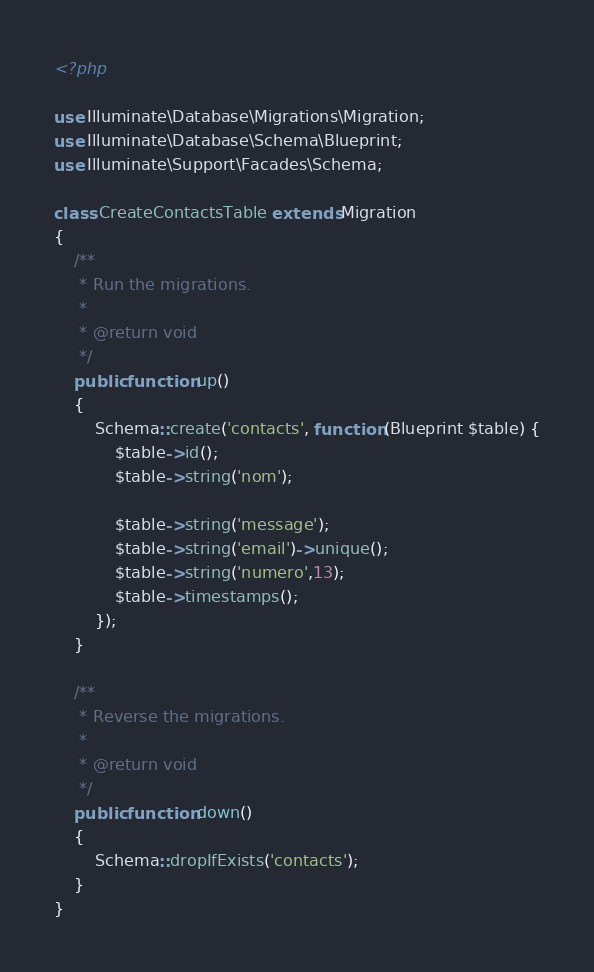Convert code to text. <code><loc_0><loc_0><loc_500><loc_500><_PHP_><?php

use Illuminate\Database\Migrations\Migration;
use Illuminate\Database\Schema\Blueprint;
use Illuminate\Support\Facades\Schema;

class CreateContactsTable extends Migration
{
    /**
     * Run the migrations.
     *
     * @return void
     */
    public function up()
    {
        Schema::create('contacts', function (Blueprint $table) {
            $table->id();
            $table->string('nom');
            
            $table->string('message');
            $table->string('email')->unique();
            $table->string('numero',13);
            $table->timestamps();
        });
    }

    /**
     * Reverse the migrations.
     *
     * @return void
     */
    public function down()
    {
        Schema::dropIfExists('contacts');
    }
}
</code> 